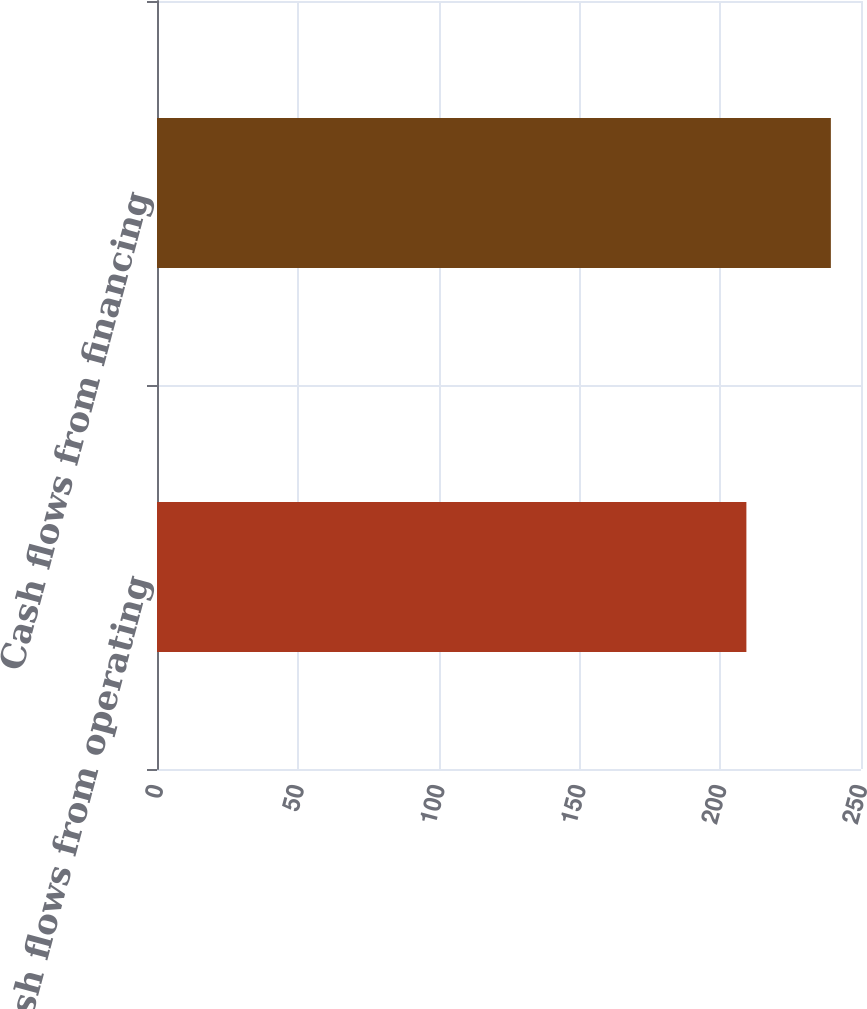Convert chart. <chart><loc_0><loc_0><loc_500><loc_500><bar_chart><fcel>Cash flows from operating<fcel>Cash flows from financing<nl><fcel>209.3<fcel>239.3<nl></chart> 